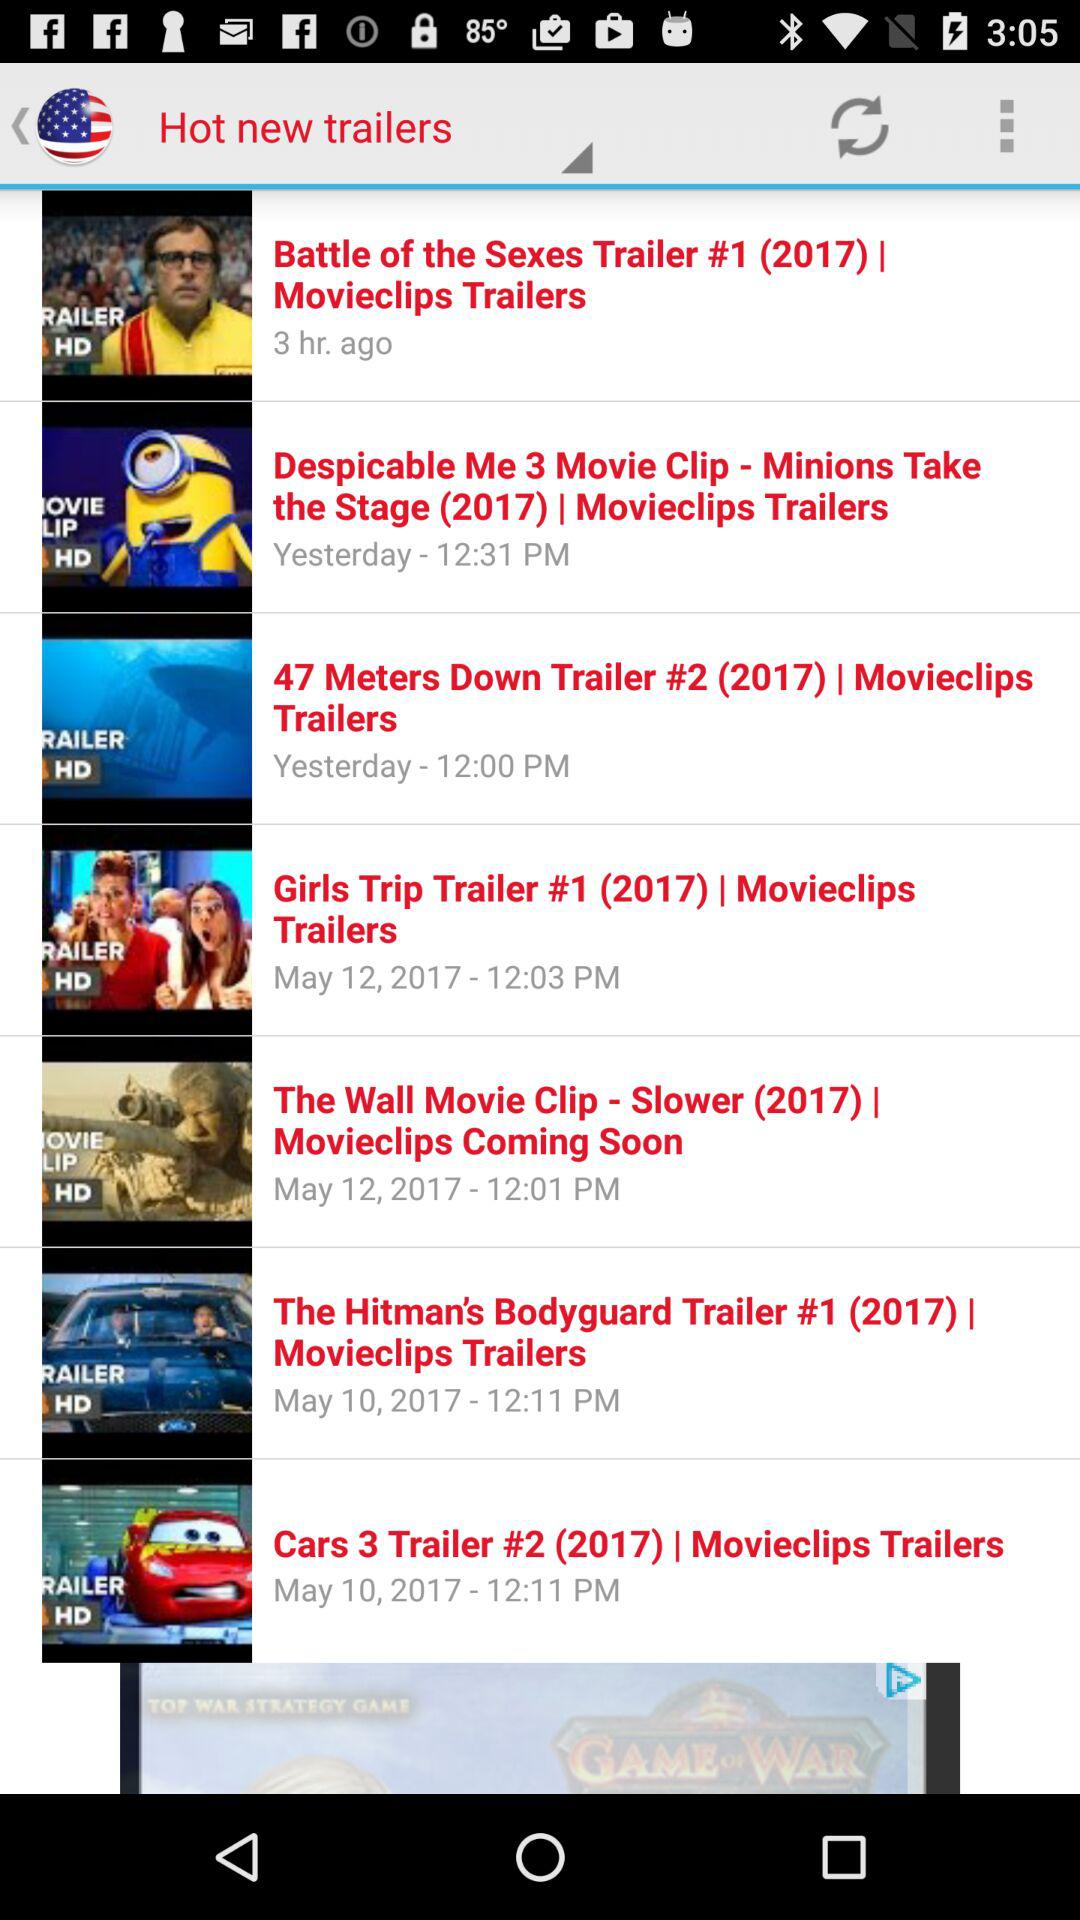How many items have a release date of May 10, 2017?
Answer the question using a single word or phrase. 2 